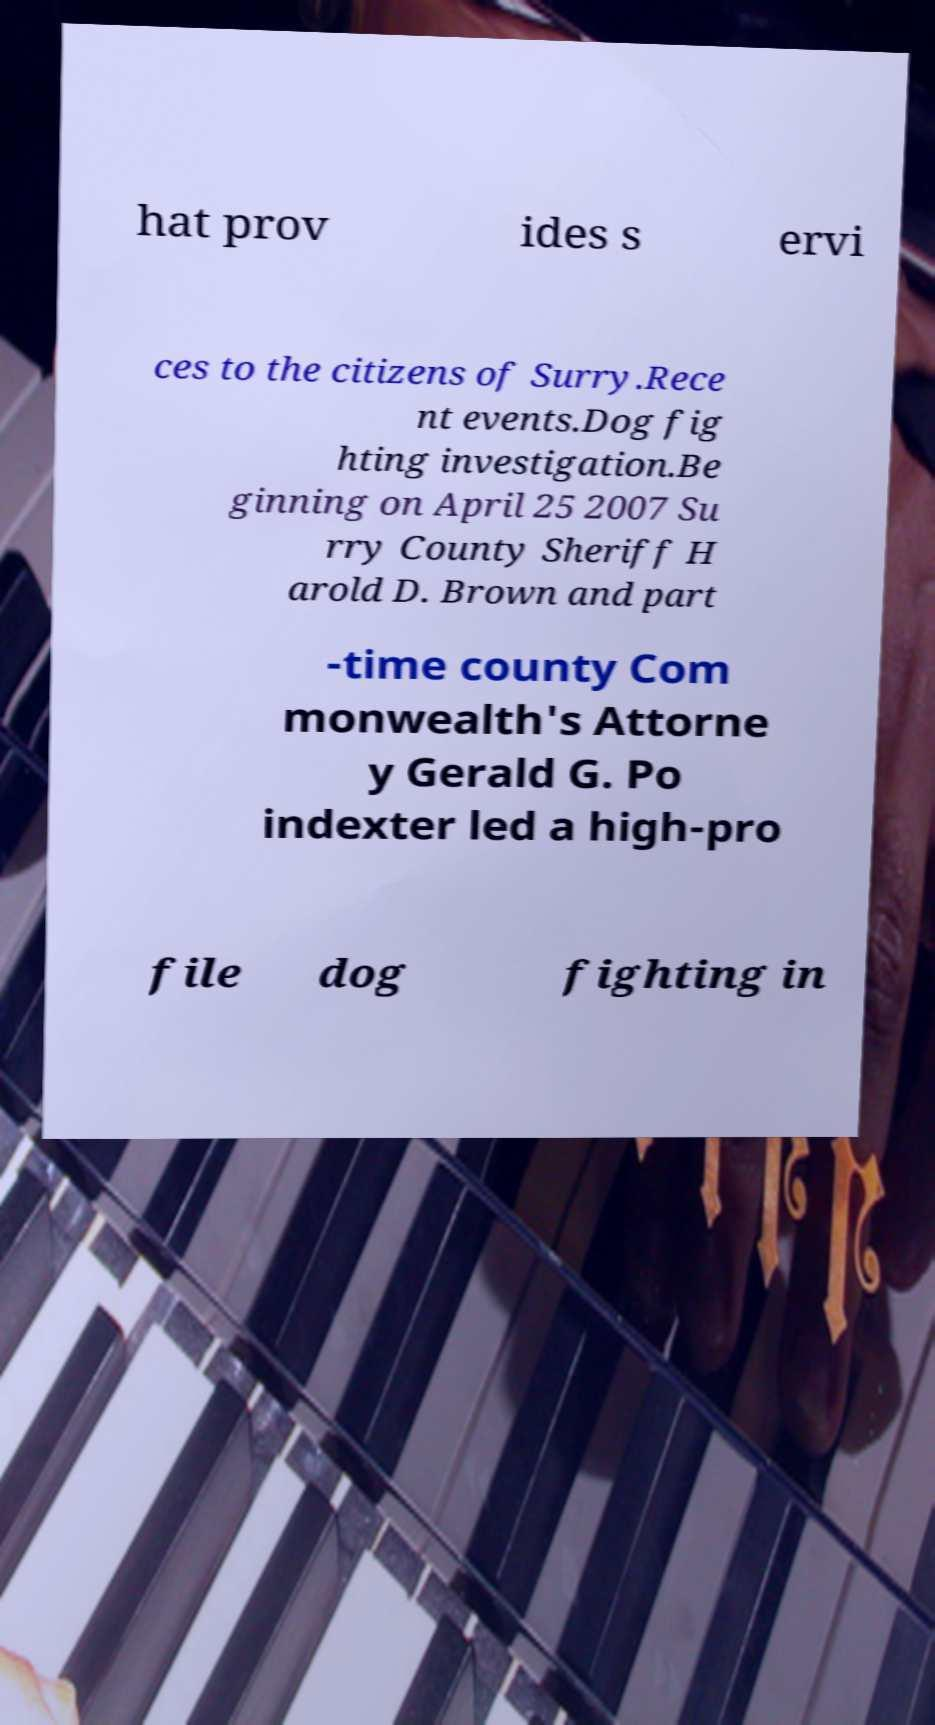For documentation purposes, I need the text within this image transcribed. Could you provide that? hat prov ides s ervi ces to the citizens of Surry.Rece nt events.Dog fig hting investigation.Be ginning on April 25 2007 Su rry County Sheriff H arold D. Brown and part -time county Com monwealth's Attorne y Gerald G. Po indexter led a high-pro file dog fighting in 